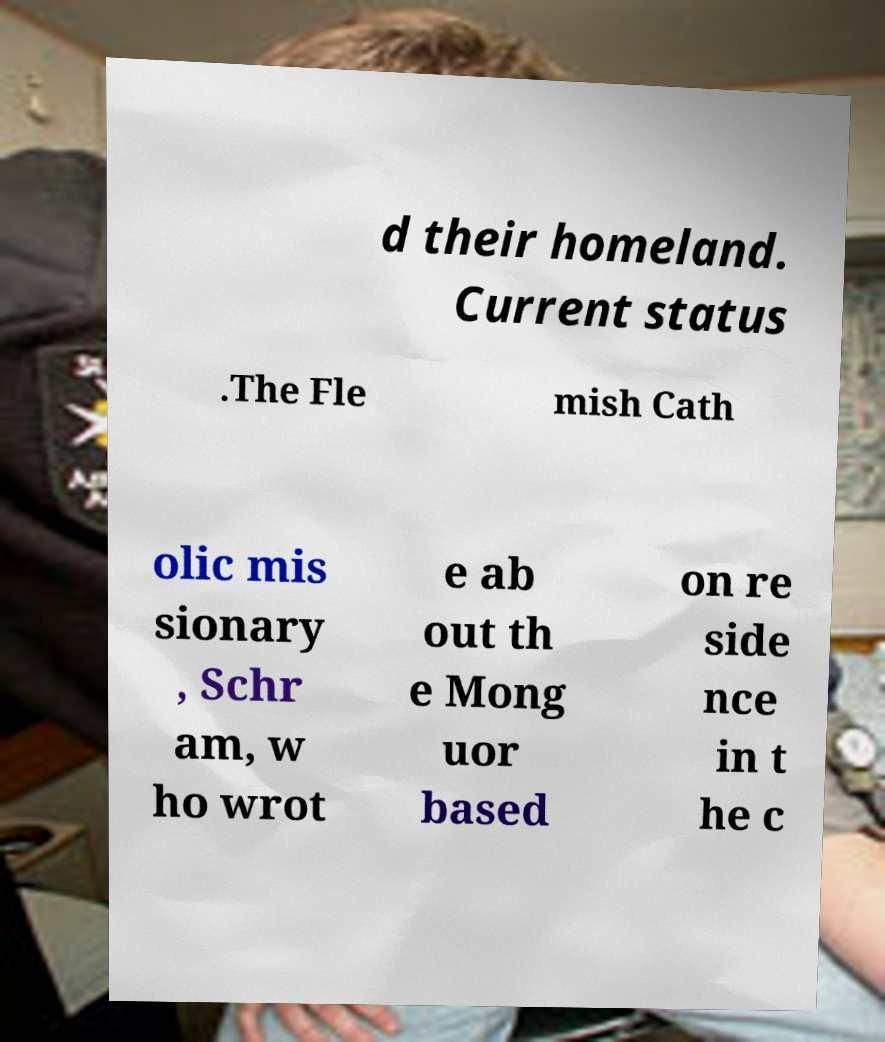For documentation purposes, I need the text within this image transcribed. Could you provide that? d their homeland. Current status .The Fle mish Cath olic mis sionary , Schr am, w ho wrot e ab out th e Mong uor based on re side nce in t he c 